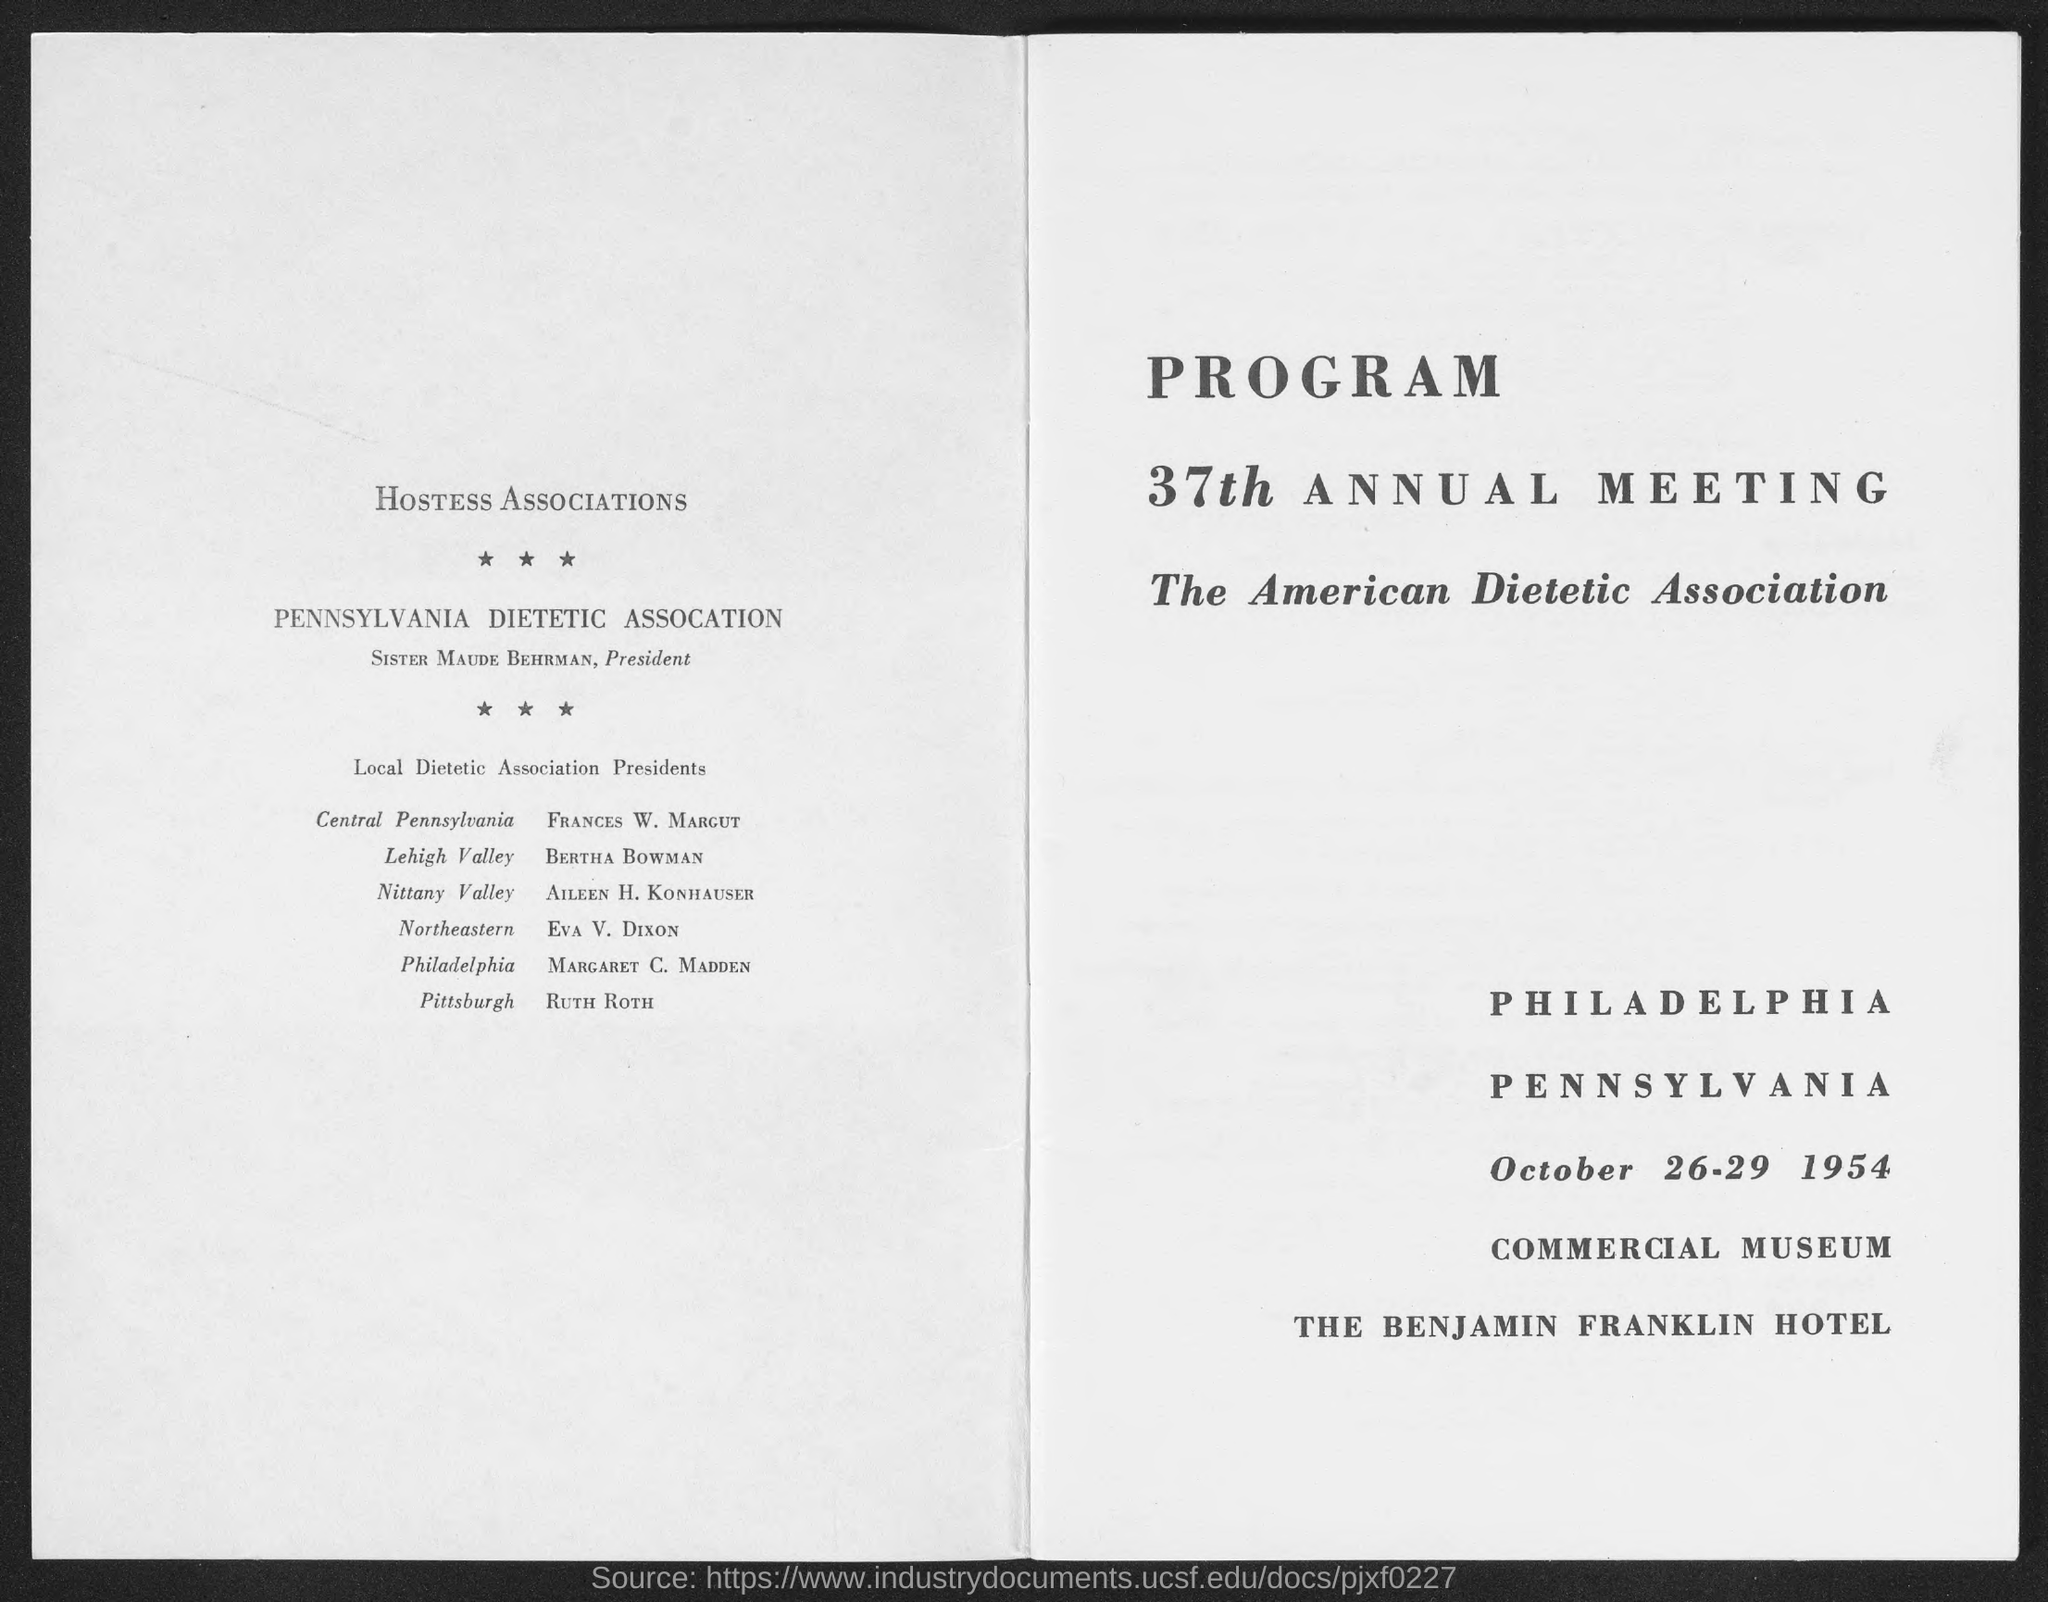Give some essential details in this illustration. The 37th Annual Meeting of The American Dietetic Association was held from October 26-29, 1954. The President of the Pennsylvania Dietetic Association is Sister Maude Behrman. 